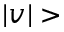Convert formula to latex. <formula><loc_0><loc_0><loc_500><loc_500>| v | ></formula> 